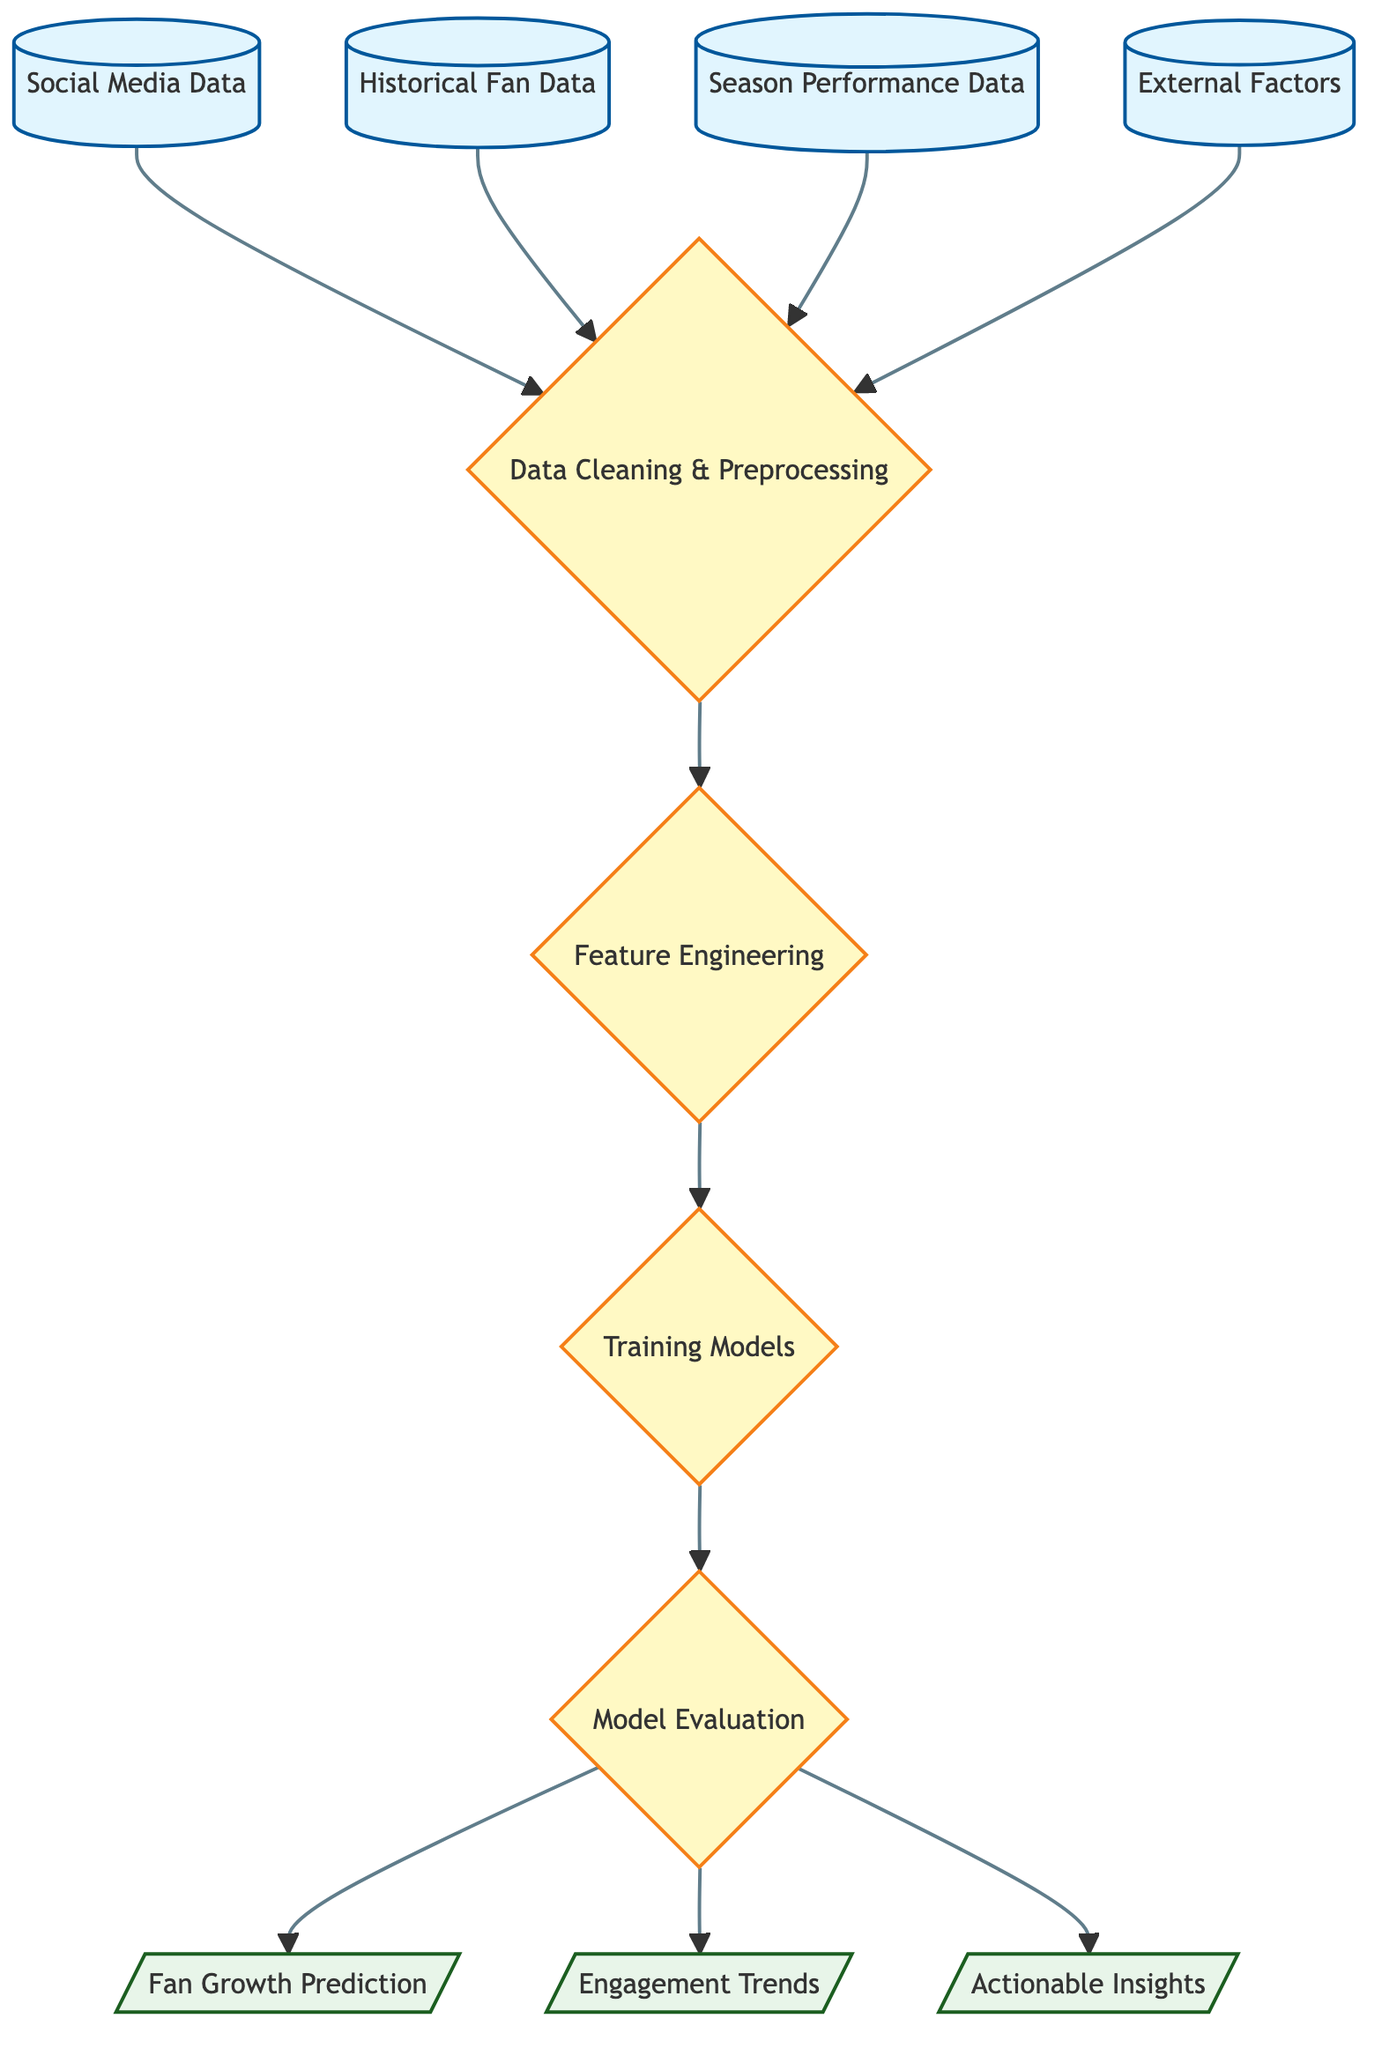What's the first input in the diagram? The first input node in the diagram is labeled "Social Media Data." It is the starting point from where the data processing begins in the flowchart.
Answer: Social Media Data How many input nodes are present? The diagram contains four input nodes, which are "Social Media Data," "Historical Fan Data," "Season Performance Data," and "External Factors." Counting these gives a total of four inputs.
Answer: 4 What is the output of the model evaluation process? The model evaluation process leads to three outputs: "Fan Growth Prediction," "Engagement Trends," and "Actionable Insights." Here, specifically, "Fan Growth Prediction" is one of the outputs.
Answer: Fan Growth Prediction Which process comes after data cleaning and preprocessing? After "Data Cleaning & Preprocessing," the next process in the flow is "Feature Engineering." This shows the progression of steps involved in preparing the data for model training.
Answer: Feature Engineering What type of data sources are used as inputs? The inputs consist of data types that include social media metrics, historical fan engagement, performance based on seasons, and external factors like promotions or events. These sources are rich for predicting fan engagement.
Answer: Data sources How does the process flow from external factors to outputs? The flow starts with "External Factors," which gets cleaned and preprocessed alongside other inputs. Then, the processed data is used for "Feature Engineering," leading to model training, evaluation, and subsequently results in outputs regarding fan growth and engagement. This shows the overall structure of how external influences impact the predictions.
Answer: External Factors to Outputs Which node connects feature engineering to training models? The connection from "Feature Engineering" to "Training Models" is direct, meaning that the enhanced features created in the previous step are used immediately for training machine learning models. This direct flow emphasizes the sequential process of data preparation and application.
Answer: Training Models What is the primary focus of the diagram? The primary focus of the diagram is on utilizing various data sources and processes to predict fan growth and analyze engagement trends, specifically for Gavin Hollowell across social platforms. The end goal revolves around actionable insights derived from this analysis.
Answer: Fan Engagement Prediction 